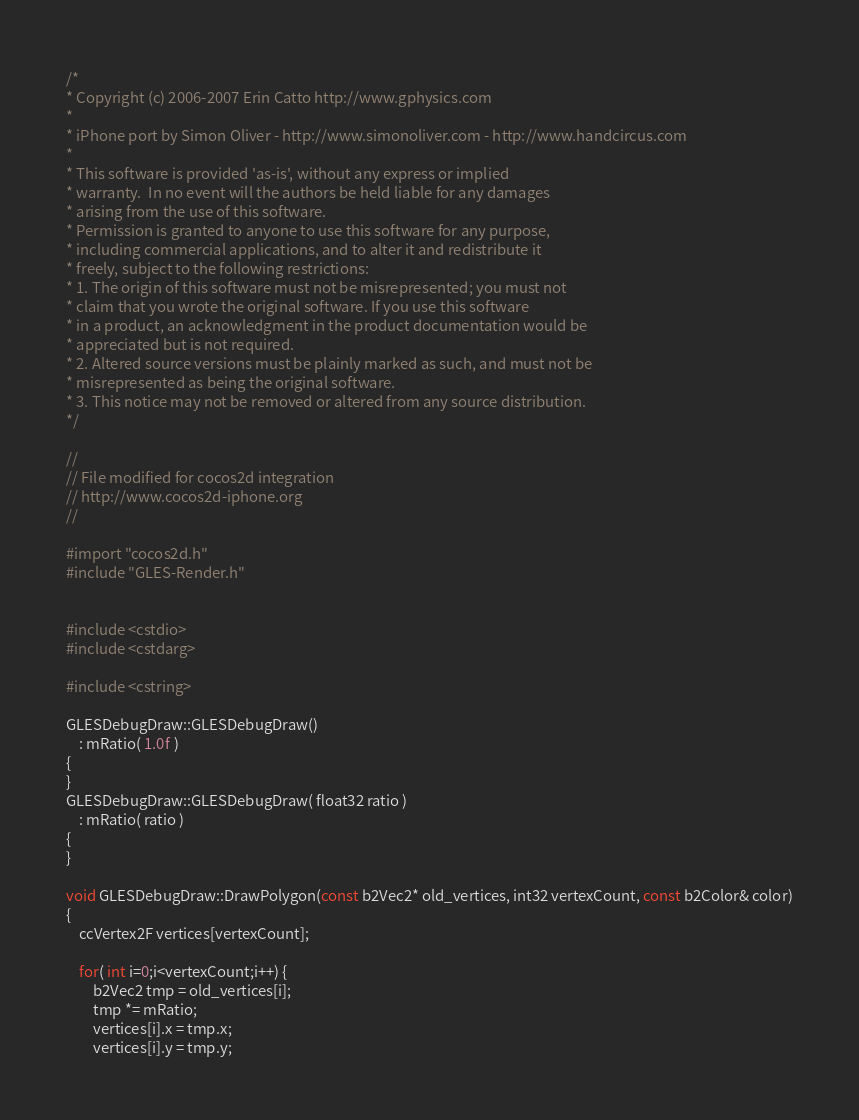<code> <loc_0><loc_0><loc_500><loc_500><_ObjectiveC_>/*
* Copyright (c) 2006-2007 Erin Catto http://www.gphysics.com
*
* iPhone port by Simon Oliver - http://www.simonoliver.com - http://www.handcircus.com
*
* This software is provided 'as-is', without any express or implied
* warranty.  In no event will the authors be held liable for any damages
* arising from the use of this software.
* Permission is granted to anyone to use this software for any purpose,
* including commercial applications, and to alter it and redistribute it
* freely, subject to the following restrictions:
* 1. The origin of this software must not be misrepresented; you must not
* claim that you wrote the original software. If you use this software
* in a product, an acknowledgment in the product documentation would be
* appreciated but is not required.
* 2. Altered source versions must be plainly marked as such, and must not be
* misrepresented as being the original software.
* 3. This notice may not be removed or altered from any source distribution.
*/

//
// File modified for cocos2d integration
// http://www.cocos2d-iphone.org
//

#import "cocos2d.h"
#include "GLES-Render.h"


#include <cstdio>
#include <cstdarg>

#include <cstring>

GLESDebugDraw::GLESDebugDraw()
	: mRatio( 1.0f )
{
}
GLESDebugDraw::GLESDebugDraw( float32 ratio )
	: mRatio( ratio )
{
}

void GLESDebugDraw::DrawPolygon(const b2Vec2* old_vertices, int32 vertexCount, const b2Color& color)
{
	ccVertex2F vertices[vertexCount];
	
	for( int i=0;i<vertexCount;i++) {
		b2Vec2 tmp = old_vertices[i];
		tmp *= mRatio;
		vertices[i].x = tmp.x;
		vertices[i].y = tmp.y;</code> 